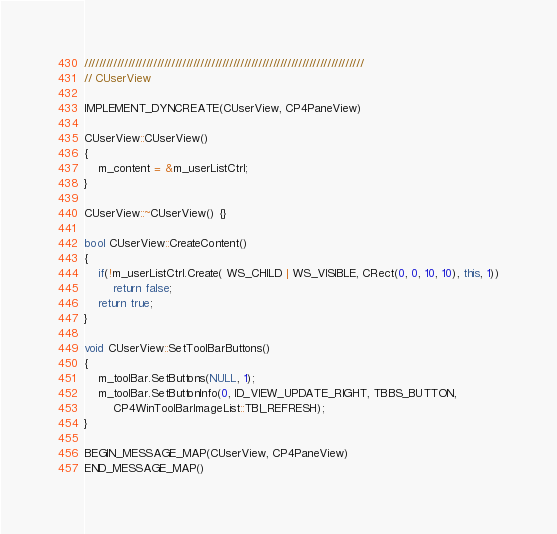<code> <loc_0><loc_0><loc_500><loc_500><_C++_>
/////////////////////////////////////////////////////////////////////////////
// CUserView

IMPLEMENT_DYNCREATE(CUserView, CP4PaneView)

CUserView::CUserView() 
{
	m_content = &m_userListCtrl;
}

CUserView::~CUserView() {}

bool CUserView::CreateContent()
{
	if(!m_userListCtrl.Create( WS_CHILD | WS_VISIBLE, CRect(0, 0, 10, 10), this, 1))
		return false;
	return true;
}

void CUserView::SetToolBarButtons()
{
	m_toolBar.SetButtons(NULL, 1);
	m_toolBar.SetButtonInfo(0, ID_VIEW_UPDATE_RIGHT, TBBS_BUTTON, 
		CP4WinToolBarImageList::TBI_REFRESH);
}

BEGIN_MESSAGE_MAP(CUserView, CP4PaneView)
END_MESSAGE_MAP()</code> 